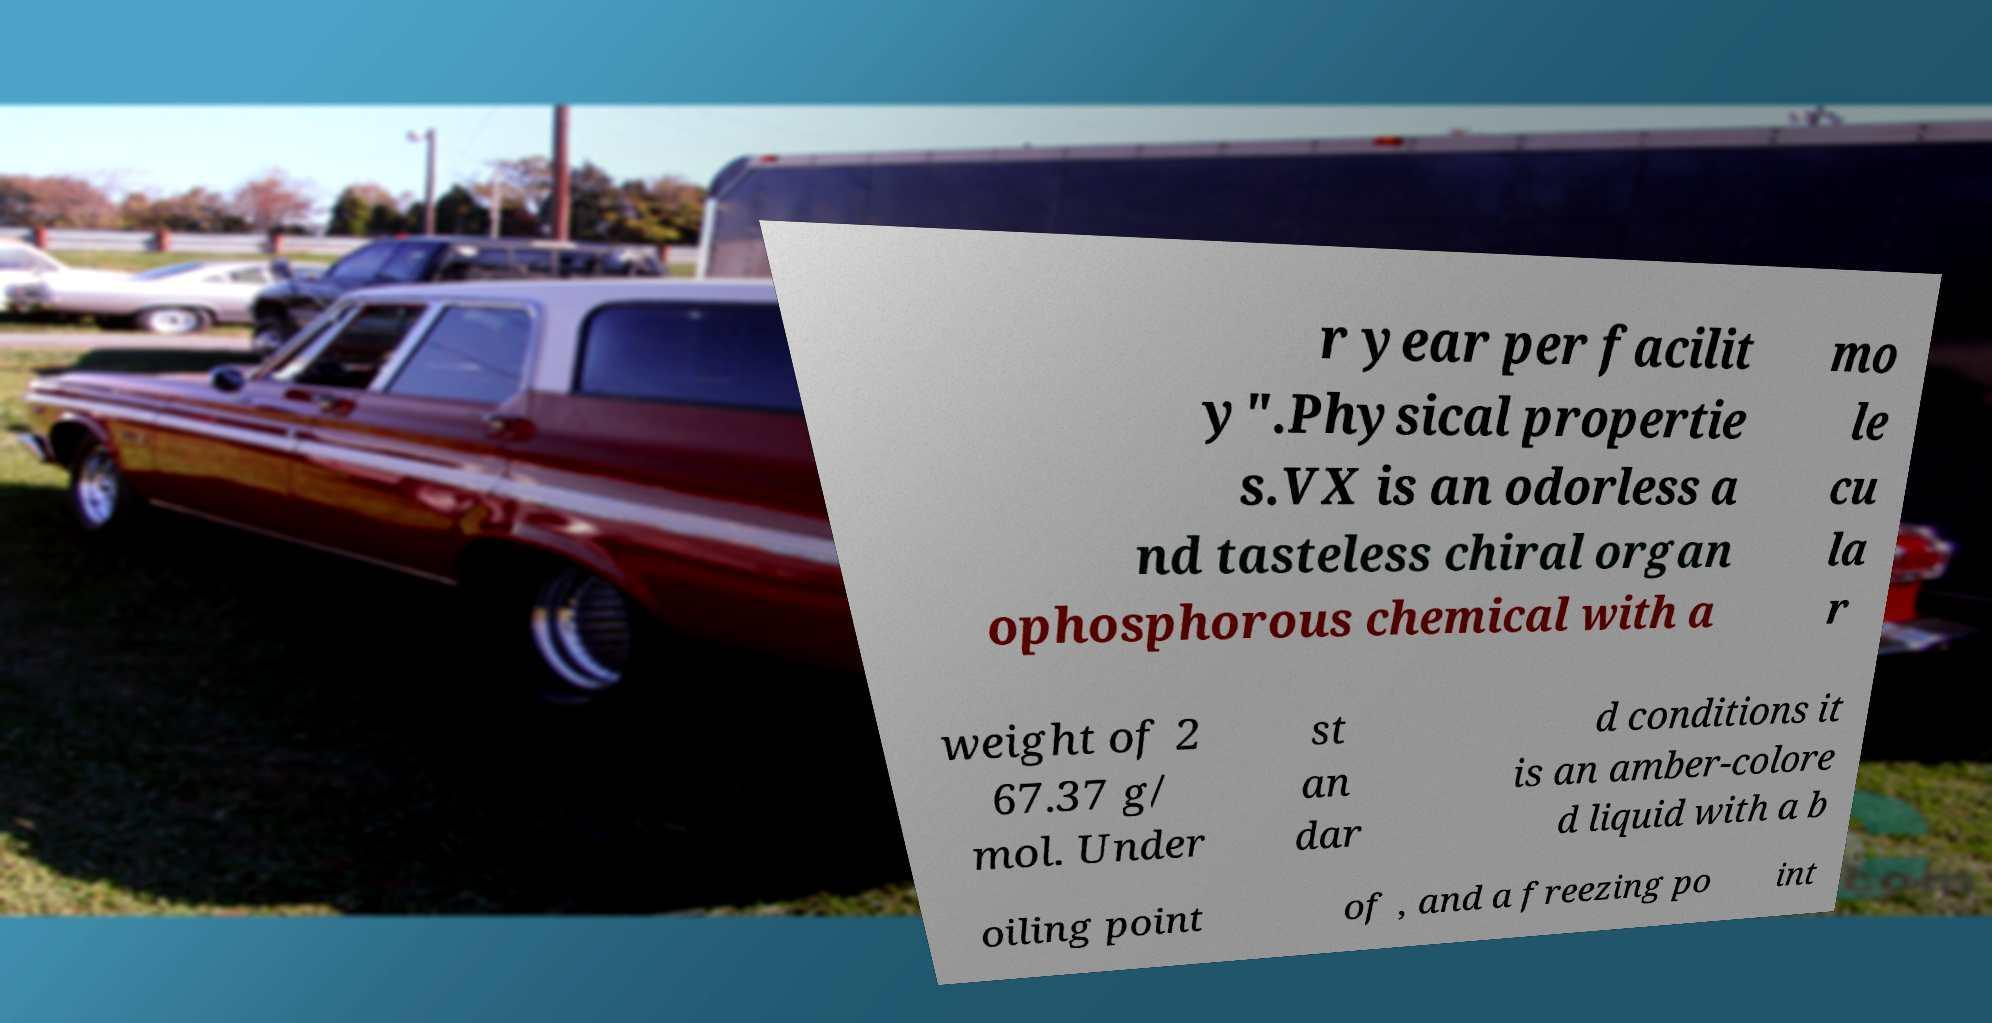Can you accurately transcribe the text from the provided image for me? r year per facilit y".Physical propertie s.VX is an odorless a nd tasteless chiral organ ophosphorous chemical with a mo le cu la r weight of 2 67.37 g/ mol. Under st an dar d conditions it is an amber-colore d liquid with a b oiling point of , and a freezing po int 